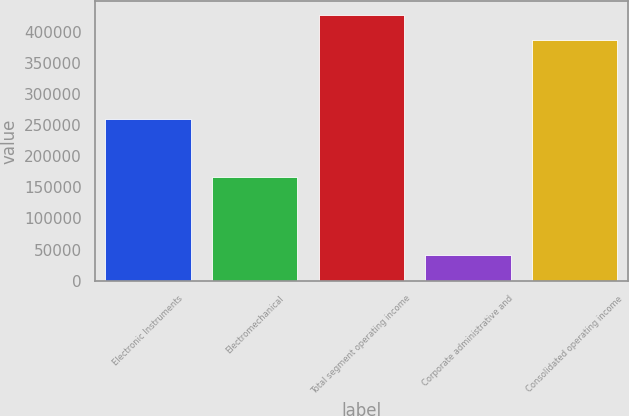Convert chart. <chart><loc_0><loc_0><loc_500><loc_500><bar_chart><fcel>Electronic Instruments<fcel>Electromechanical<fcel>Total segment operating income<fcel>Corporate administrative and<fcel>Consolidated operating income<nl><fcel>260338<fcel>167166<fcel>427504<fcel>40930<fcel>386574<nl></chart> 